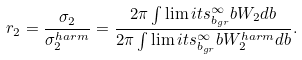Convert formula to latex. <formula><loc_0><loc_0><loc_500><loc_500>r _ { 2 } = \frac { \sigma _ { 2 } } { \sigma ^ { h a r m } _ { 2 } } = \frac { 2 \pi \int \lim i t s _ { b _ { g r } } ^ { \infty } b W _ { 2 } d b } { 2 \pi \int \lim i t s _ { b _ { g r } } ^ { \infty } b W ^ { h a r m } _ { 2 } d b } .</formula> 